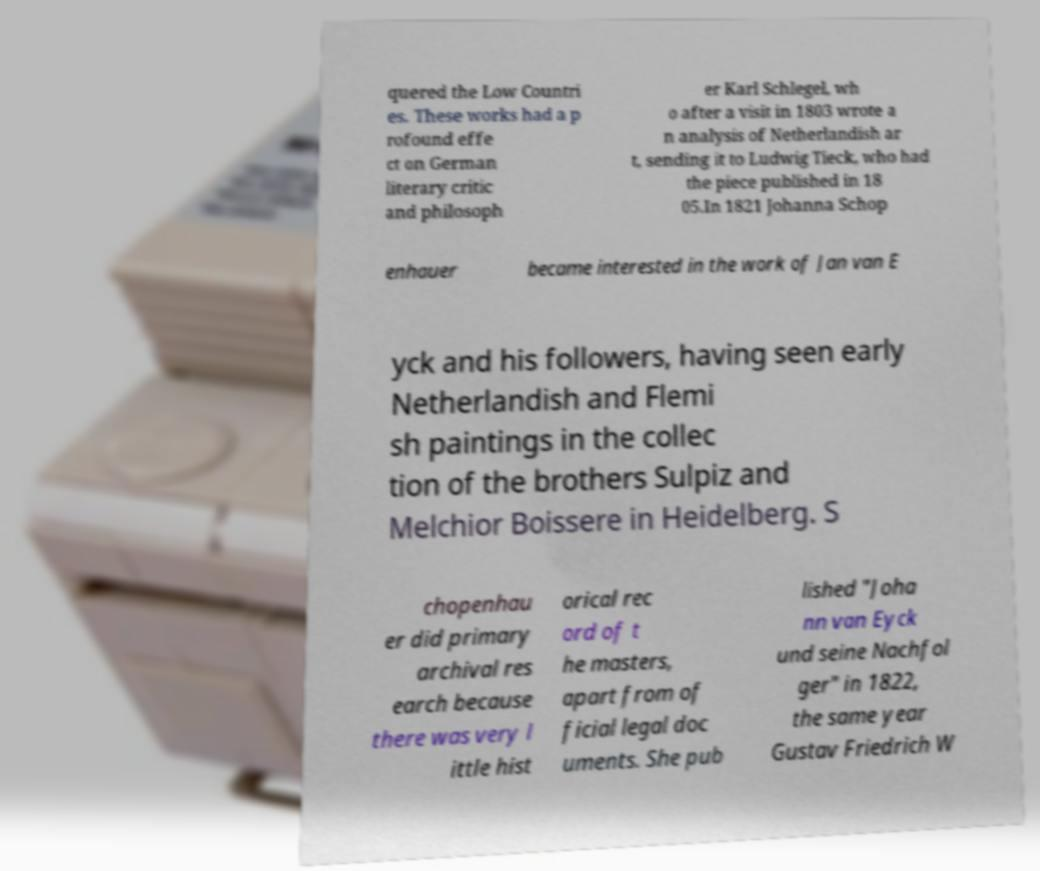I need the written content from this picture converted into text. Can you do that? quered the Low Countri es. These works had a p rofound effe ct on German literary critic and philosoph er Karl Schlegel, wh o after a visit in 1803 wrote a n analysis of Netherlandish ar t, sending it to Ludwig Tieck, who had the piece published in 18 05.In 1821 Johanna Schop enhauer became interested in the work of Jan van E yck and his followers, having seen early Netherlandish and Flemi sh paintings in the collec tion of the brothers Sulpiz and Melchior Boissere in Heidelberg. S chopenhau er did primary archival res earch because there was very l ittle hist orical rec ord of t he masters, apart from of ficial legal doc uments. She pub lished "Joha nn van Eyck und seine Nachfol ger" in 1822, the same year Gustav Friedrich W 